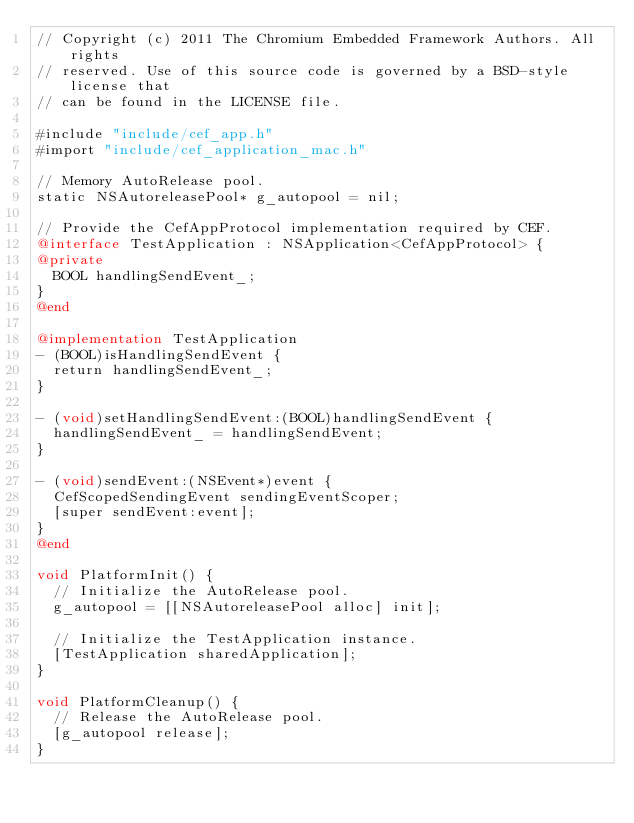Convert code to text. <code><loc_0><loc_0><loc_500><loc_500><_ObjectiveC_>// Copyright (c) 2011 The Chromium Embedded Framework Authors. All rights
// reserved. Use of this source code is governed by a BSD-style license that
// can be found in the LICENSE file.

#include "include/cef_app.h"
#import "include/cef_application_mac.h"

// Memory AutoRelease pool.
static NSAutoreleasePool* g_autopool = nil;

// Provide the CefAppProtocol implementation required by CEF.
@interface TestApplication : NSApplication<CefAppProtocol> {
@private
  BOOL handlingSendEvent_;
}
@end

@implementation TestApplication
- (BOOL)isHandlingSendEvent {
  return handlingSendEvent_;
}

- (void)setHandlingSendEvent:(BOOL)handlingSendEvent {
  handlingSendEvent_ = handlingSendEvent;
}

- (void)sendEvent:(NSEvent*)event {
  CefScopedSendingEvent sendingEventScoper;
  [super sendEvent:event];
}
@end

void PlatformInit() {
  // Initialize the AutoRelease pool.
  g_autopool = [[NSAutoreleasePool alloc] init];
  
  // Initialize the TestApplication instance.
  [TestApplication sharedApplication];
}

void PlatformCleanup() {
  // Release the AutoRelease pool.
  [g_autopool release];
}

</code> 